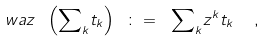Convert formula to latex. <formula><loc_0><loc_0><loc_500><loc_500>\ w a z \ \left ( { \sum } _ { k } t _ { k } \right ) \ \colon = \ { \sum } _ { k } z ^ { k } t _ { k } \ \ ,</formula> 